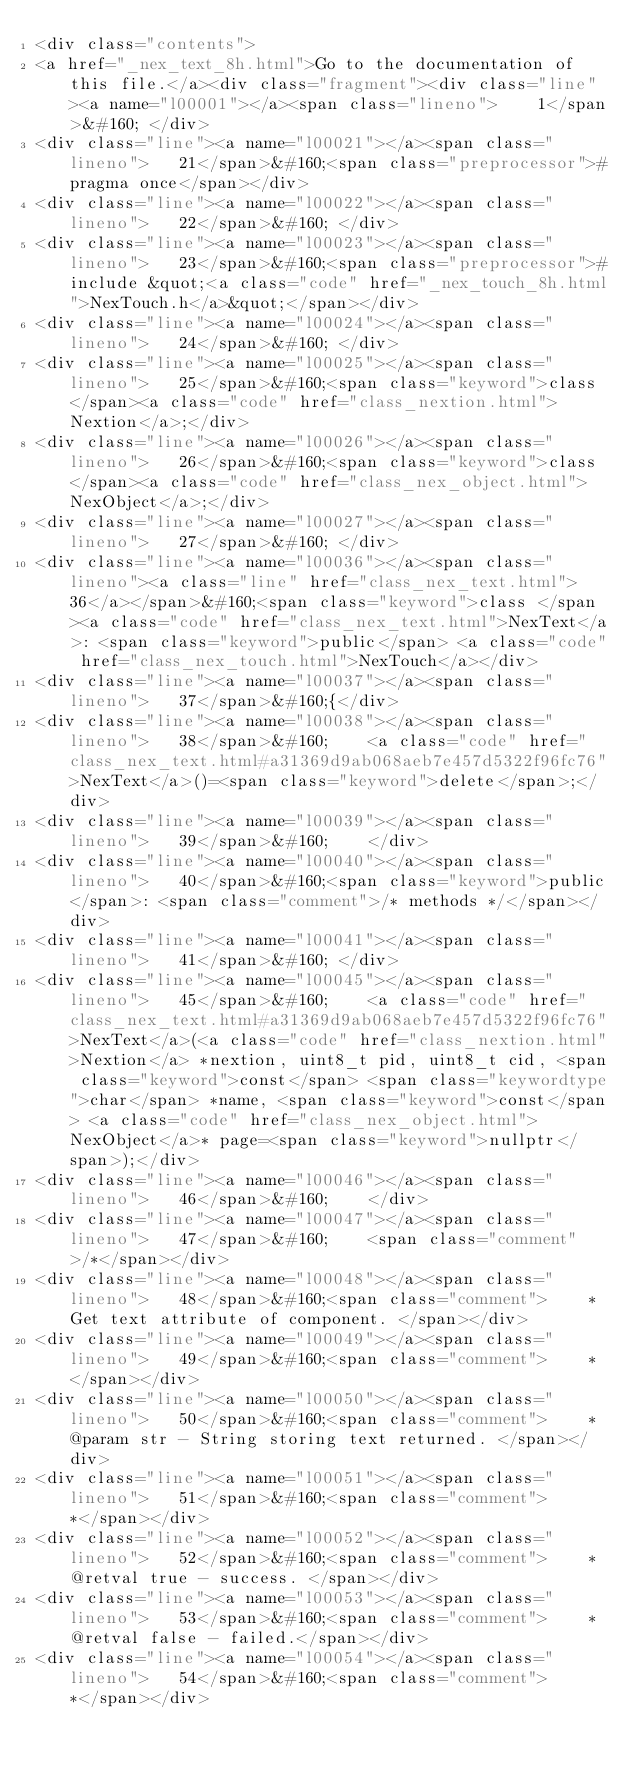Convert code to text. <code><loc_0><loc_0><loc_500><loc_500><_HTML_><div class="contents">
<a href="_nex_text_8h.html">Go to the documentation of this file.</a><div class="fragment"><div class="line"><a name="l00001"></a><span class="lineno">    1</span>&#160; </div>
<div class="line"><a name="l00021"></a><span class="lineno">   21</span>&#160;<span class="preprocessor">#pragma once</span></div>
<div class="line"><a name="l00022"></a><span class="lineno">   22</span>&#160; </div>
<div class="line"><a name="l00023"></a><span class="lineno">   23</span>&#160;<span class="preprocessor">#include &quot;<a class="code" href="_nex_touch_8h.html">NexTouch.h</a>&quot;</span></div>
<div class="line"><a name="l00024"></a><span class="lineno">   24</span>&#160; </div>
<div class="line"><a name="l00025"></a><span class="lineno">   25</span>&#160;<span class="keyword">class </span><a class="code" href="class_nextion.html">Nextion</a>;</div>
<div class="line"><a name="l00026"></a><span class="lineno">   26</span>&#160;<span class="keyword">class </span><a class="code" href="class_nex_object.html">NexObject</a>;</div>
<div class="line"><a name="l00027"></a><span class="lineno">   27</span>&#160; </div>
<div class="line"><a name="l00036"></a><span class="lineno"><a class="line" href="class_nex_text.html">   36</a></span>&#160;<span class="keyword">class </span><a class="code" href="class_nex_text.html">NexText</a>: <span class="keyword">public</span> <a class="code" href="class_nex_touch.html">NexTouch</a></div>
<div class="line"><a name="l00037"></a><span class="lineno">   37</span>&#160;{</div>
<div class="line"><a name="l00038"></a><span class="lineno">   38</span>&#160;    <a class="code" href="class_nex_text.html#a31369d9ab068aeb7e457d5322f96fc76">NexText</a>()=<span class="keyword">delete</span>;</div>
<div class="line"><a name="l00039"></a><span class="lineno">   39</span>&#160;    </div>
<div class="line"><a name="l00040"></a><span class="lineno">   40</span>&#160;<span class="keyword">public</span>: <span class="comment">/* methods */</span></div>
<div class="line"><a name="l00041"></a><span class="lineno">   41</span>&#160; </div>
<div class="line"><a name="l00045"></a><span class="lineno">   45</span>&#160;    <a class="code" href="class_nex_text.html#a31369d9ab068aeb7e457d5322f96fc76">NexText</a>(<a class="code" href="class_nextion.html">Nextion</a> *nextion, uint8_t pid, uint8_t cid, <span class="keyword">const</span> <span class="keywordtype">char</span> *name, <span class="keyword">const</span> <a class="code" href="class_nex_object.html">NexObject</a>* page=<span class="keyword">nullptr</span>);</div>
<div class="line"><a name="l00046"></a><span class="lineno">   46</span>&#160;    </div>
<div class="line"><a name="l00047"></a><span class="lineno">   47</span>&#160;    <span class="comment">/*</span></div>
<div class="line"><a name="l00048"></a><span class="lineno">   48</span>&#160;<span class="comment">    * Get text attribute of component. </span></div>
<div class="line"><a name="l00049"></a><span class="lineno">   49</span>&#160;<span class="comment">    * </span></div>
<div class="line"><a name="l00050"></a><span class="lineno">   50</span>&#160;<span class="comment">    * @param str - String storing text returned. </span></div>
<div class="line"><a name="l00051"></a><span class="lineno">   51</span>&#160;<span class="comment">    *</span></div>
<div class="line"><a name="l00052"></a><span class="lineno">   52</span>&#160;<span class="comment">    * @retval true - success. </span></div>
<div class="line"><a name="l00053"></a><span class="lineno">   53</span>&#160;<span class="comment">    * @retval false - failed.</span></div>
<div class="line"><a name="l00054"></a><span class="lineno">   54</span>&#160;<span class="comment">    *</span></div></code> 